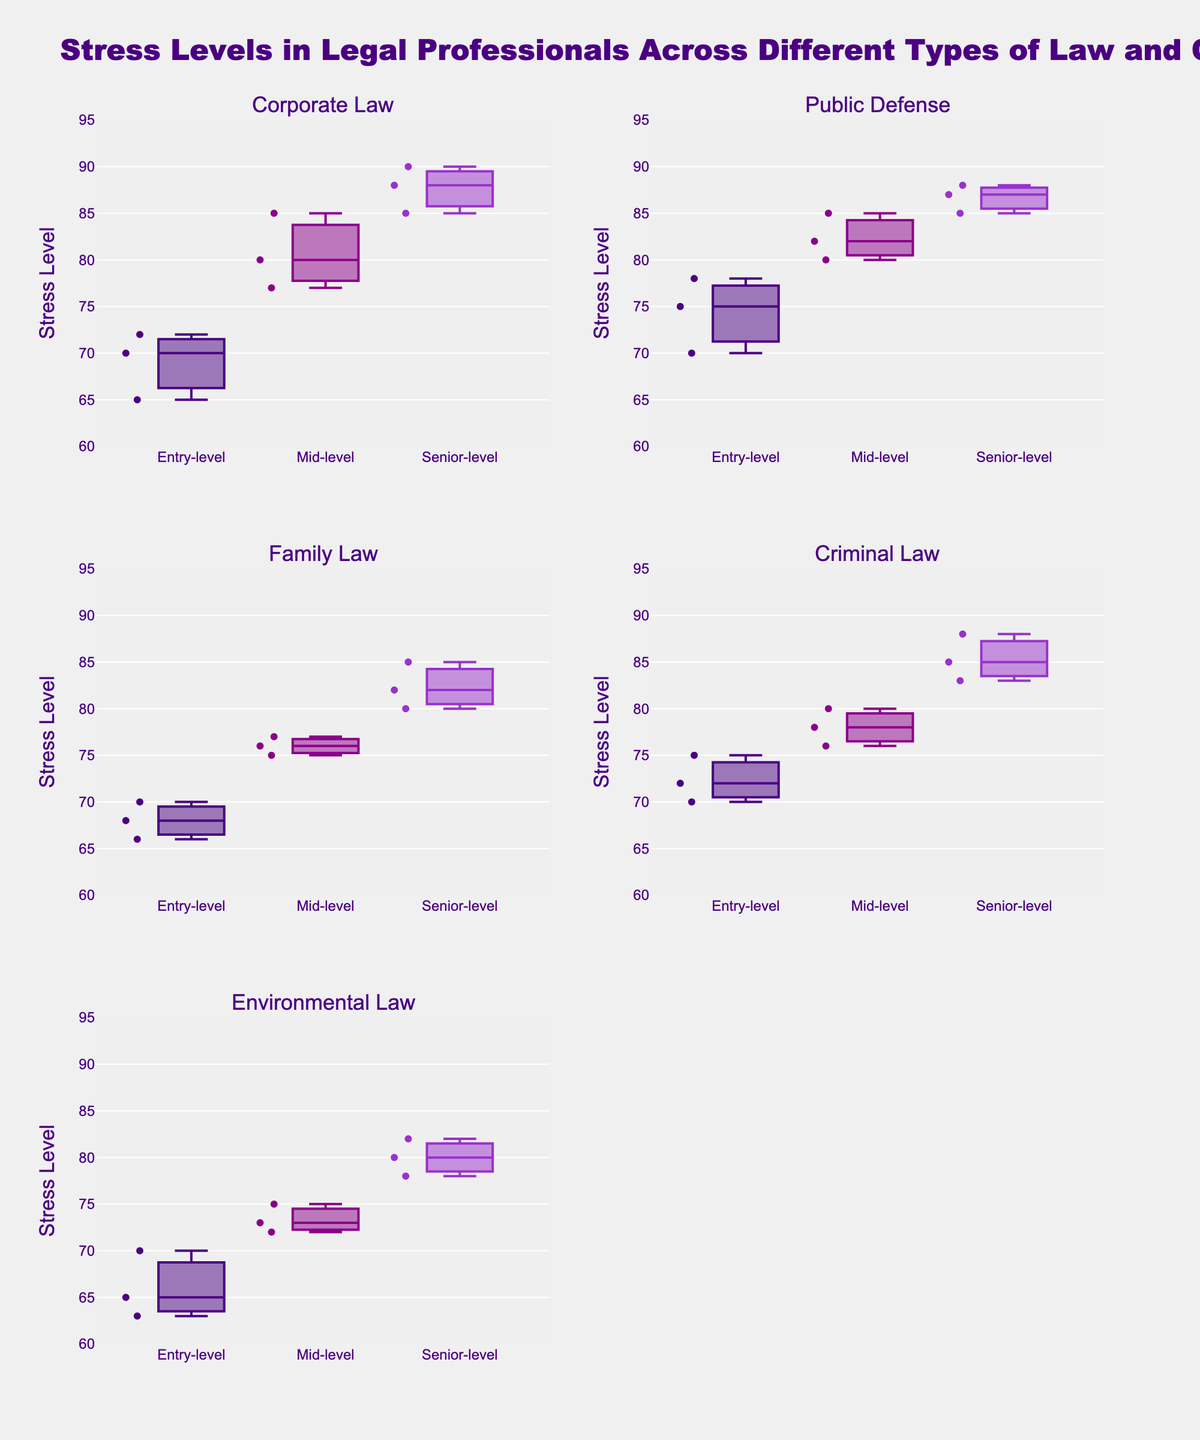What is the title of the figure? The title is displayed at the top of the figure and reads "Stress Levels in Legal Professionals Across Different Types of Law and Career Stages".
Answer: Stress Levels in Legal Professionals Across Different Types of Law and Career Stages Which career stage has the highest average stress level in Corporate Law? By examining the positions of the boxes and their medians (lines within the boxes), the Senior-level in Corporate Law has the highest average stress level compared to Entry-level and Mid-level.
Answer: Senior-level How does the median stress level in Entry-level Public Defense compare to Entry-level Family Law? The median is the line inside each box. Comparing these lines in the two subplots, it's evident that Entry-level Public Defense has a higher median stress level than Entry-level Family Law.
Answer: Public Defense has a higher median Which type of law shows the lowest median stress level for Senior-level professionals? Comparing the median lines of Senior-level across all five subplots, Environmental Law has the lowest median stress level for Senior-level professionals.
Answer: Environmental Law How many career stages are displayed in each subplot? Each subplot contains three career stages: Entry-level, Mid-level, and Senior-level. This can be seen from the three box plots for each type of law.
Answer: Three Which career stage in Criminal Law shows the most variability in stress levels? The variability in a box plot is represented by the length of the box and the spread of the outliers. The Entry-level stage in Criminal Law appears to have the largest interquartile range (IQR) and spread of points, indicating the most variability.
Answer: Entry-level Is there a type of law where Mid-level professionals have higher stress levels than Senior-level professionals? Comparing Mid-level and Senior-level box plots across all subplots, there isn't a type of law where the Mid-level plots display higher median stress levels than those of the Senior-level.
Answer: No What is the range of stress levels displayed on the y-axis? The y-axis, labeled "Stress Level", ranges from 60 to 95. This is directly visible at the left side of the figure where the y-axis is marked.
Answer: 60 to 95 Are there any outliers in the Senior-level Corporate Law data points? Outliers in a box plot are typically shown as points outside the whiskers. In the Senior-level Corporate Law subplot, no data points are clearly separated from the whiskers, indicating no outliers.
Answer: No 